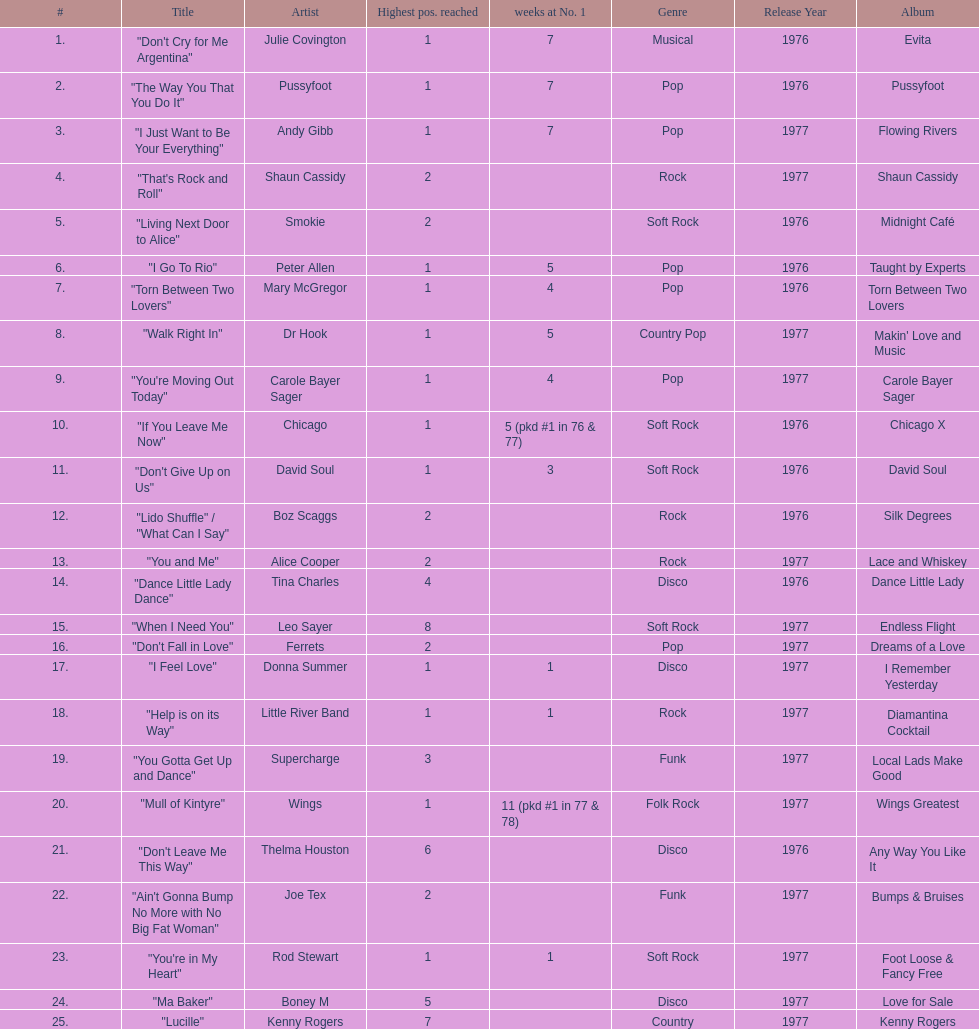What was the number of weeks that julie covington's single " don't cry for me argentinia," was at number 1 in 1977? 7. Could you help me parse every detail presented in this table? {'header': ['#', 'Title', 'Artist', 'Highest pos. reached', 'weeks at No. 1', 'Genre', 'Release Year', 'Album'], 'rows': [['1.', '"Don\'t Cry for Me Argentina"', 'Julie Covington', '1', '7', 'Musical', '1976', 'Evita'], ['2.', '"The Way You That You Do It"', 'Pussyfoot', '1', '7', 'Pop', '1976', 'Pussyfoot'], ['3.', '"I Just Want to Be Your Everything"', 'Andy Gibb', '1', '7', 'Pop', '1977', 'Flowing Rivers'], ['4.', '"That\'s Rock and Roll"', 'Shaun Cassidy', '2', '', 'Rock', '1977', 'Shaun Cassidy'], ['5.', '"Living Next Door to Alice"', 'Smokie', '2', '', 'Soft Rock', '1976', 'Midnight Café'], ['6.', '"I Go To Rio"', 'Peter Allen', '1', '5', 'Pop', '1976', 'Taught by Experts'], ['7.', '"Torn Between Two Lovers"', 'Mary McGregor', '1', '4', 'Pop', '1976', 'Torn Between Two Lovers'], ['8.', '"Walk Right In"', 'Dr Hook', '1', '5', 'Country Pop', '1977', "Makin' Love and Music"], ['9.', '"You\'re Moving Out Today"', 'Carole Bayer Sager', '1', '4', 'Pop', '1977', 'Carole Bayer Sager'], ['10.', '"If You Leave Me Now"', 'Chicago', '1', '5 (pkd #1 in 76 & 77)', 'Soft Rock', '1976', 'Chicago X'], ['11.', '"Don\'t Give Up on Us"', 'David Soul', '1', '3', 'Soft Rock', '1976', 'David Soul'], ['12.', '"Lido Shuffle" / "What Can I Say"', 'Boz Scaggs', '2', '', 'Rock', '1976', 'Silk Degrees'], ['13.', '"You and Me"', 'Alice Cooper', '2', '', 'Rock', '1977', 'Lace and Whiskey'], ['14.', '"Dance Little Lady Dance"', 'Tina Charles', '4', '', 'Disco', '1976', 'Dance Little Lady'], ['15.', '"When I Need You"', 'Leo Sayer', '8', '', 'Soft Rock', '1977', 'Endless Flight'], ['16.', '"Don\'t Fall in Love"', 'Ferrets', '2', '', 'Pop', '1977', 'Dreams of a Love'], ['17.', '"I Feel Love"', 'Donna Summer', '1', '1', 'Disco', '1977', 'I Remember Yesterday'], ['18.', '"Help is on its Way"', 'Little River Band', '1', '1', 'Rock', '1977', 'Diamantina Cocktail'], ['19.', '"You Gotta Get Up and Dance"', 'Supercharge', '3', '', 'Funk', '1977', 'Local Lads Make Good'], ['20.', '"Mull of Kintyre"', 'Wings', '1', '11 (pkd #1 in 77 & 78)', 'Folk Rock', '1977', 'Wings Greatest'], ['21.', '"Don\'t Leave Me This Way"', 'Thelma Houston', '6', '', 'Disco', '1976', 'Any Way You Like It'], ['22.', '"Ain\'t Gonna Bump No More with No Big Fat Woman"', 'Joe Tex', '2', '', 'Funk', '1977', 'Bumps & Bruises'], ['23.', '"You\'re in My Heart"', 'Rod Stewart', '1', '1', 'Soft Rock', '1977', 'Foot Loose & Fancy Free'], ['24.', '"Ma Baker"', 'Boney M', '5', '', 'Disco', '1977', 'Love for Sale'], ['25.', '"Lucille"', 'Kenny Rogers', '7', '', 'Country', '1977', 'Kenny Rogers']]} 